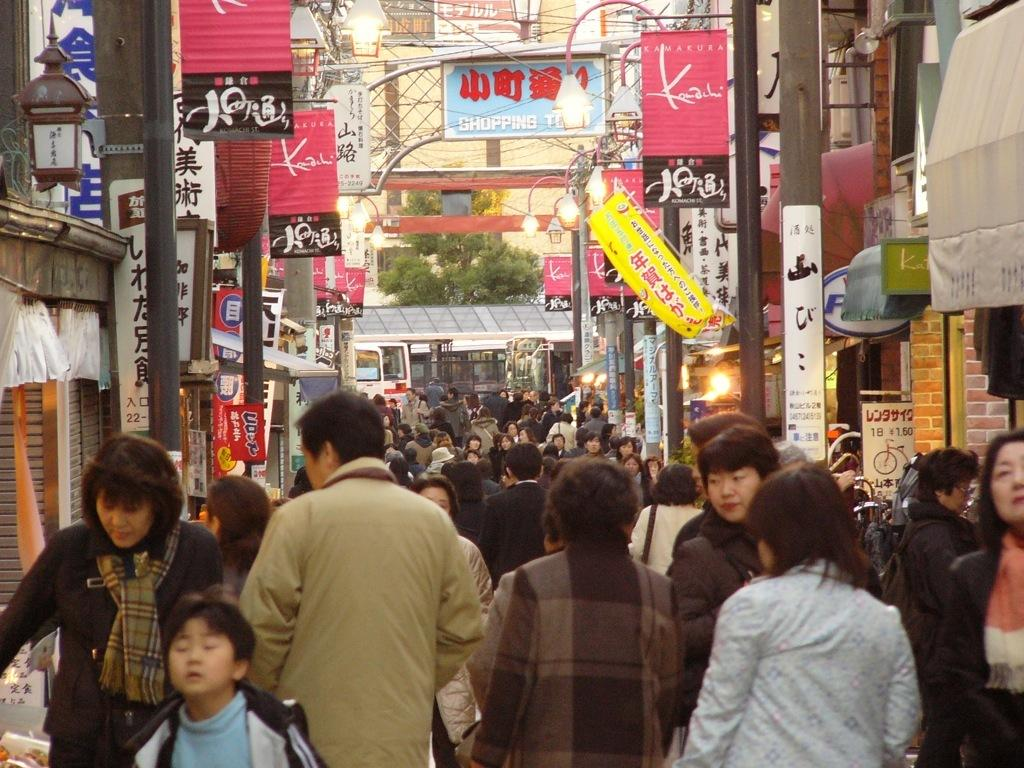What is happening on the road in the image? There are many people walking on the road in the image. What can be seen on both sides of the road? There are buildings on the left and right sides of the road. What other structures are present along with the buildings? There are poles and boards along with the buildings. What can be seen in the distance in the image? Trees are visible in the background of the image. What is the name of the meal being served in the image? There is no meal being served in the image; it features people walking on a road with buildings and trees in the background. 